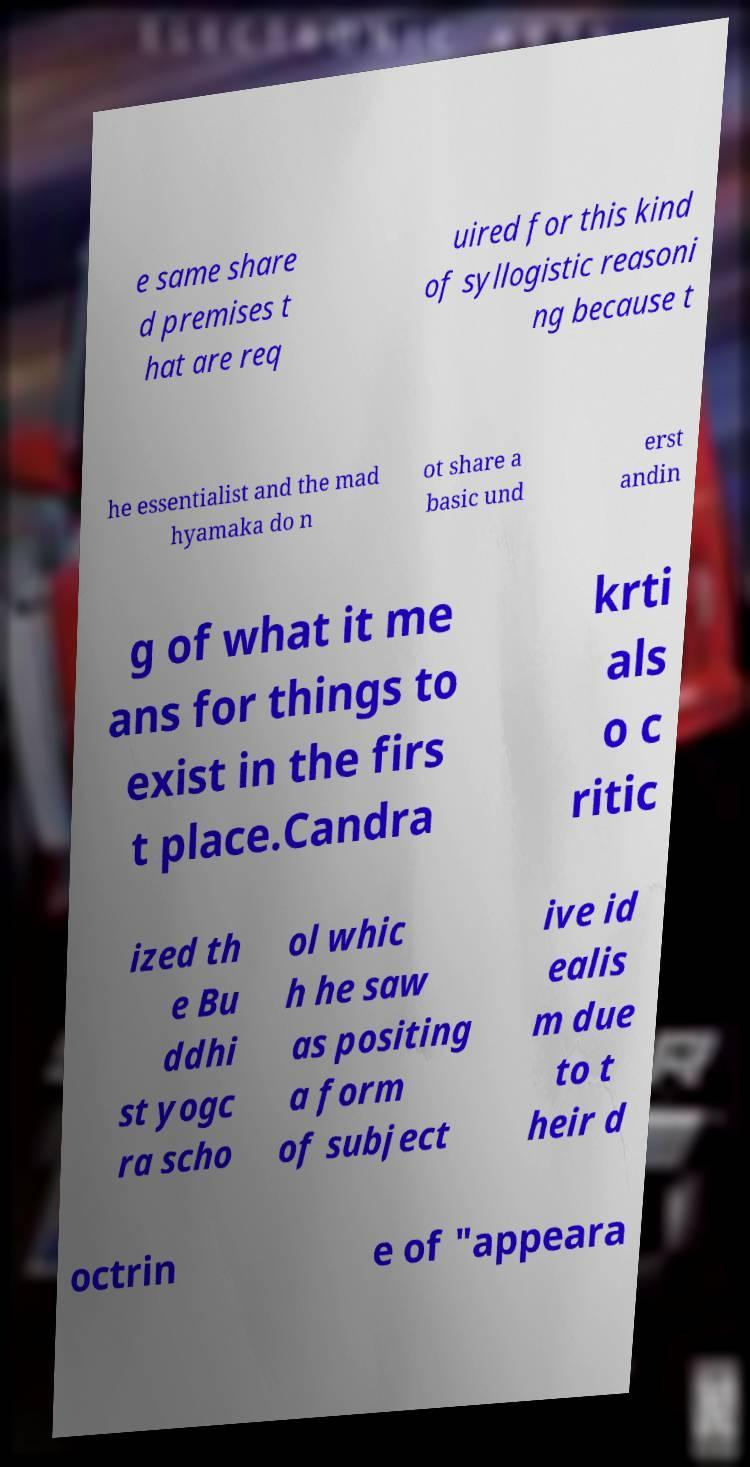Could you assist in decoding the text presented in this image and type it out clearly? e same share d premises t hat are req uired for this kind of syllogistic reasoni ng because t he essentialist and the mad hyamaka do n ot share a basic und erst andin g of what it me ans for things to exist in the firs t place.Candra krti als o c ritic ized th e Bu ddhi st yogc ra scho ol whic h he saw as positing a form of subject ive id ealis m due to t heir d octrin e of "appeara 